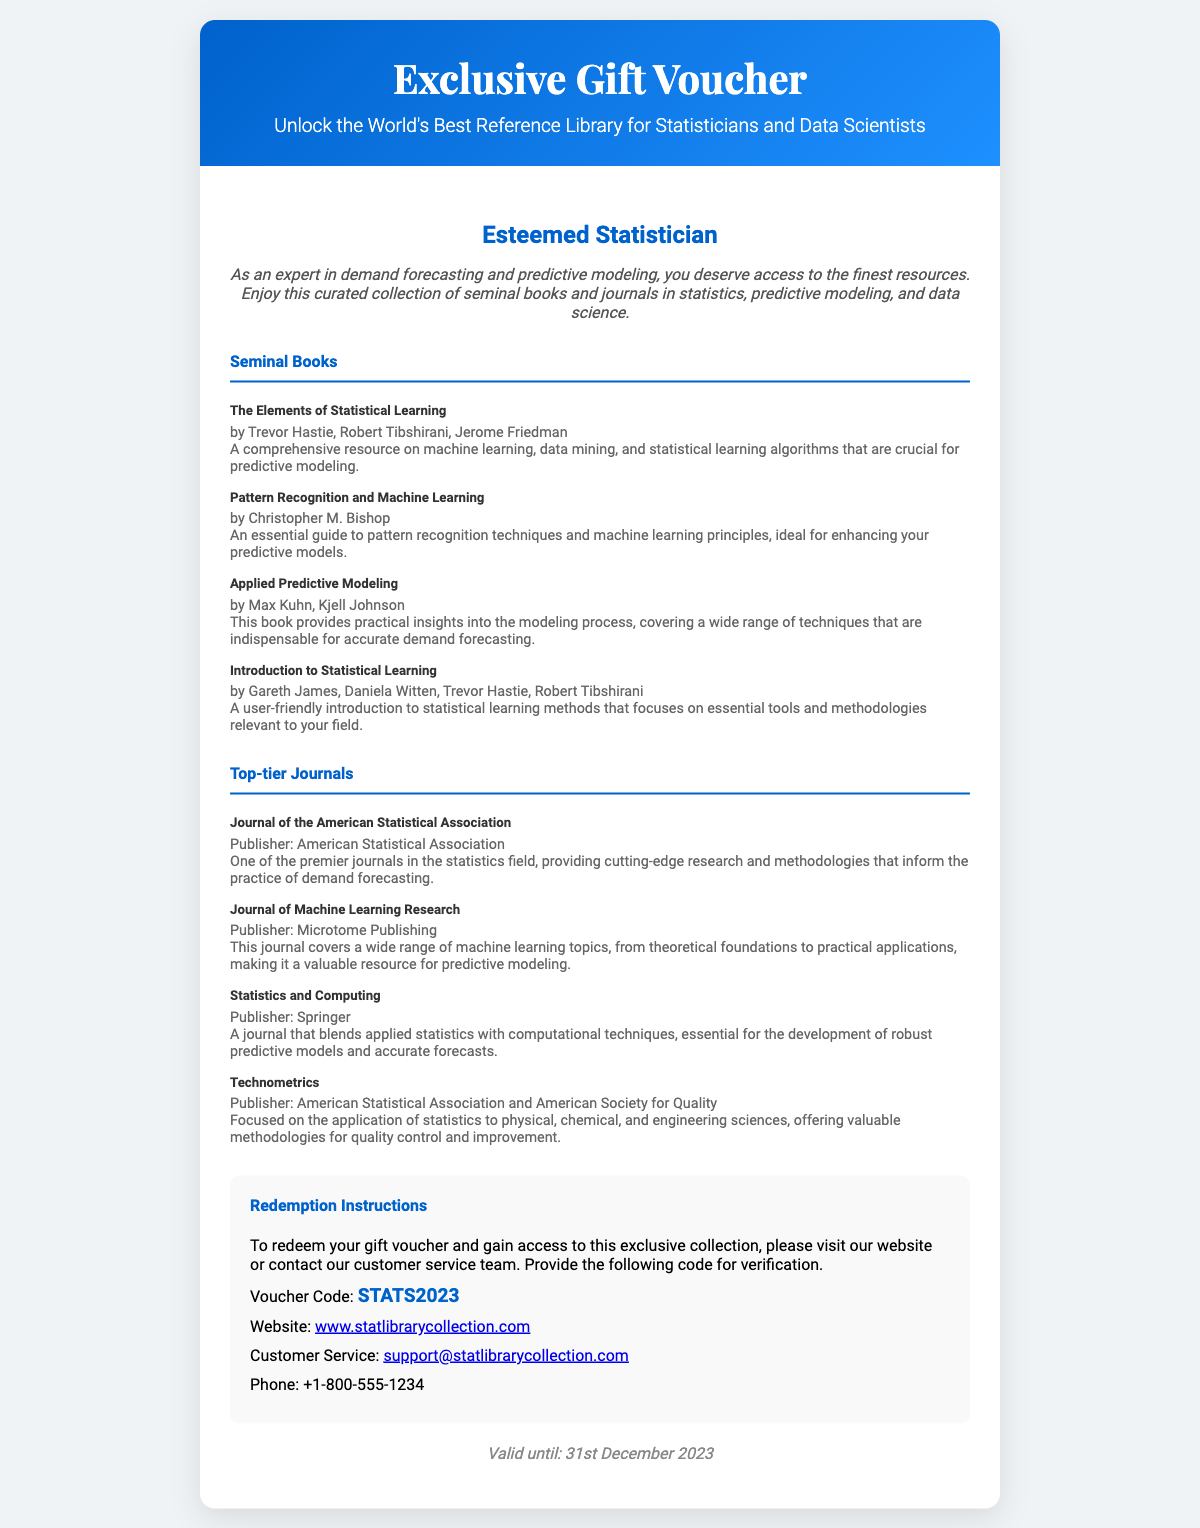What is the name of the gift voucher? The name of the gift voucher is mentioned in the header at the top of the document.
Answer: Exclusive Gift Voucher What is the voucher code? The voucher code is listed in the redemption section of the document for verification.
Answer: STATS2023 Who is the recipient of the voucher? The intended recipient is specified in the recipient section, indicating who the voucher is for.
Answer: Esteemed Statistician What is the expiry date of the voucher? The expiry date is stated at the bottom of the document, indicating until when the voucher is valid.
Answer: 31st December 2023 Name one of the seminal books included in the collection. The books are listed in the collection section, and one can be extracted from the list provided.
Answer: The Elements of Statistical Learning Which journal is published by the Springer? The journals are listed in the top-tier journals section, and one of them is associated with the publisher.
Answer: Statistics and Computing What is the website to redeem the voucher? The website is provided in the redemption instructions for accessing the collection.
Answer: www.statlibrarycollection.com How many seminal books are mentioned in the document? The number of books is identified by counting the items listed under the Seminal Books section.
Answer: Four What is the purpose of this document? The purpose is outlined in the title and introductory description at the top of the document.
Answer: To unlock the world's best reference library for statisticians and data scientists 